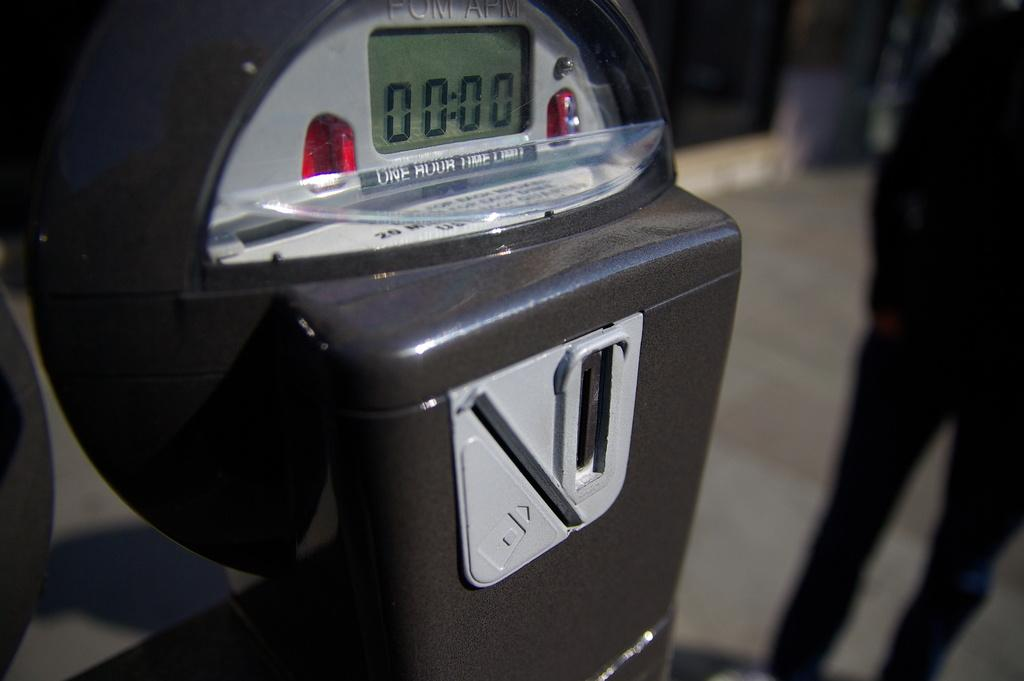<image>
Offer a succinct explanation of the picture presented. A parking meter has a digital display that reads 00:00. 